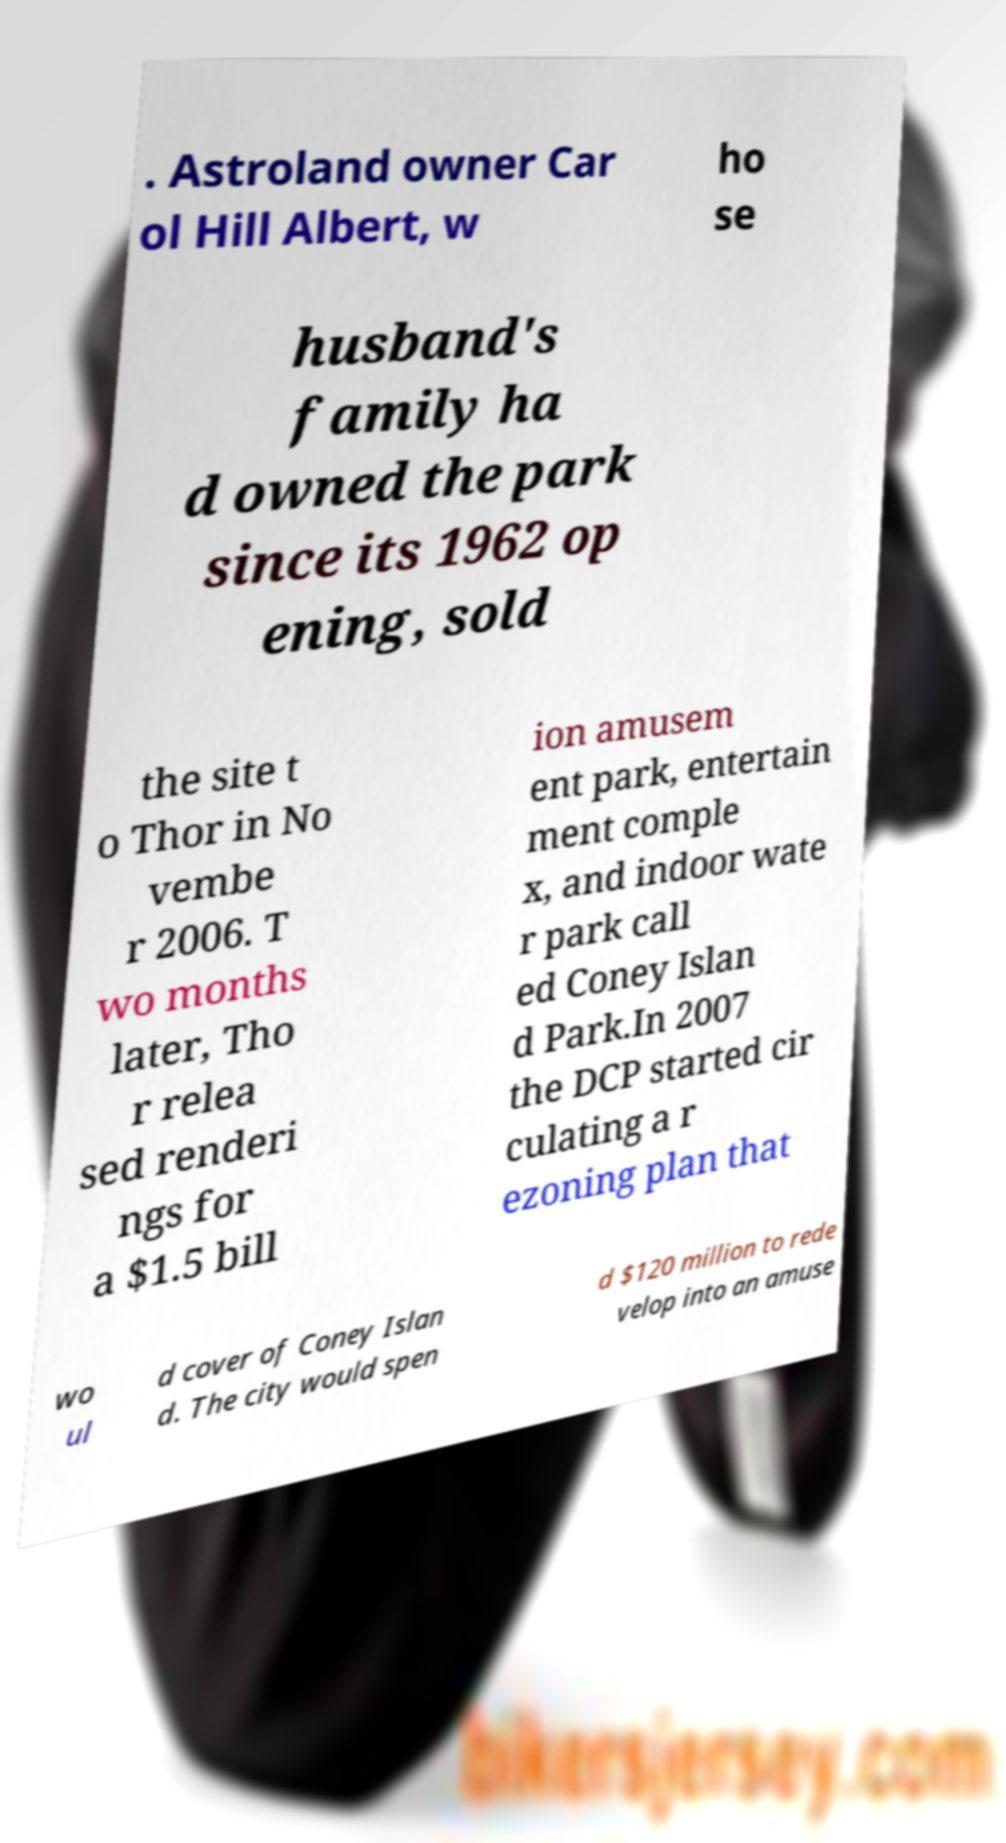Can you read and provide the text displayed in the image?This photo seems to have some interesting text. Can you extract and type it out for me? . Astroland owner Car ol Hill Albert, w ho se husband's family ha d owned the park since its 1962 op ening, sold the site t o Thor in No vembe r 2006. T wo months later, Tho r relea sed renderi ngs for a $1.5 bill ion amusem ent park, entertain ment comple x, and indoor wate r park call ed Coney Islan d Park.In 2007 the DCP started cir culating a r ezoning plan that wo ul d cover of Coney Islan d. The city would spen d $120 million to rede velop into an amuse 